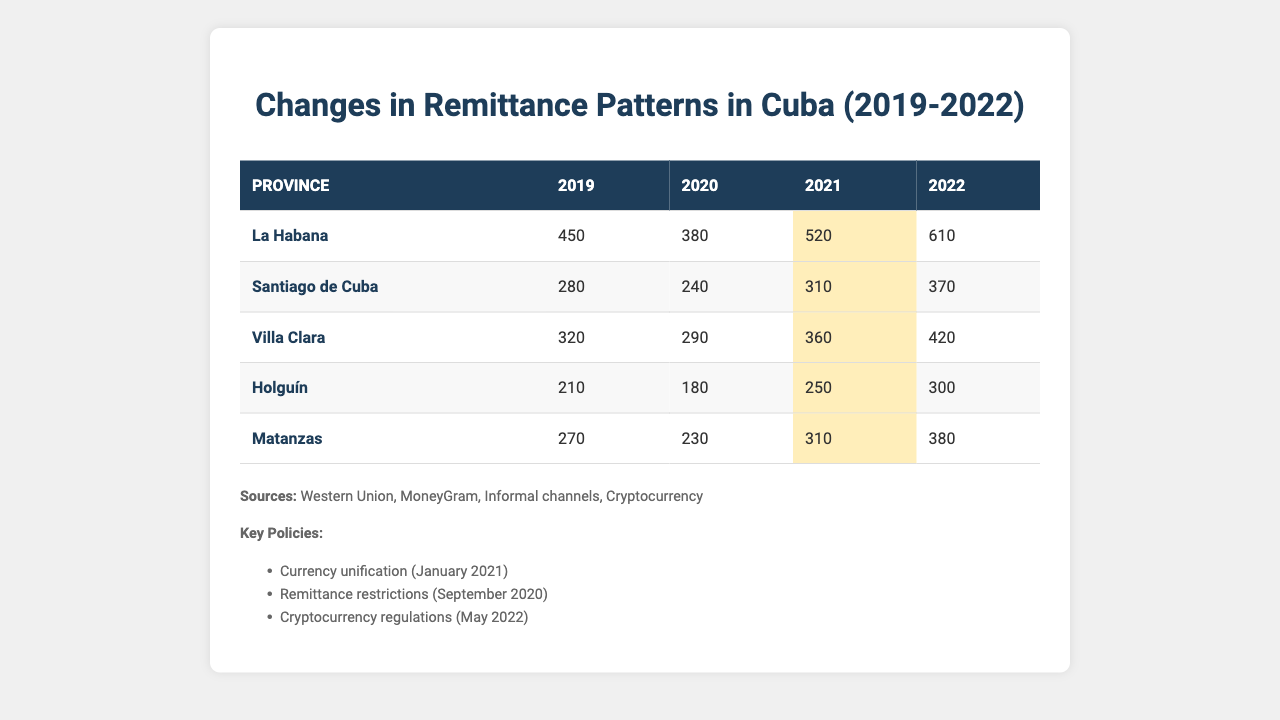What was the remittance amount in La Habana in 2021? According to the table, the remittance amount in La Habana for the year 2021 is directly indicated as 520.
Answer: 520 Which province experienced the highest remittance in 2022? The table shows the remittance amounts for 2022, with La Habana at 610, Santiago de Cuba at 370, Villa Clara at 420, Holguín at 300, and Matanzas at 380. La Habana has the highest remittance amount at 610.
Answer: La Habana What was the percentage increase in remittances from 2019 to 2022 for Holguín? For Holguín, remittances were 210 in 2019 and rose to 300 in 2022. The increase is calculated as (300 - 210) / 210 * 100 = 42.86%.
Answer: 42.86% Did remittances in Santiago de Cuba decrease from 2019 to 2020? The table shows that Santiago de Cuba had remittances of 280 in 2019 and 240 in 2020, indicating a decrease.
Answer: Yes What is the total remittance received in Villa Clara over the four years (2019-2022)? The remittances in Villa Clara are 320 in 2019, 290 in 2020, 360 in 2021, and 420 in 2022. The total can be calculated as 320 + 290 + 360 + 420 = 1390.
Answer: 1390 Which years saw an increase in remittances compared to the previous year for La Habana? Looking at the remittance data for La Habana, it shows an increase from 2019 to 2021 (from 450 to 520) and from 2021 to 2022 (from 520 to 610). However, it decreased from 2019 to 2020 (from 450 to 380). Therefore, the years with increases are 2021 and 2022.
Answer: 2021 and 2022 What was the average remittance amount for Matanzas from 2019 to 2022? Matanzas had remittances of 270 in 2019, 230 in 2020, 310 in 2021, and 380 in 2022. The average is (270 + 230 + 310 + 380) / 4 = 297.5.
Answer: 297.5 Is it true that all provinces experienced an increase in remittances from 2021 to 2022? By examining the data, Holguín (250 to 300), Matanzas (310 to 380), Villa Clara (360 to 420), Santiago de Cuba (310 to 370), and La Habana (520 to 610) all increased from 2021 to 2022. Therefore, the statement is true.
Answer: Yes Which province had the second highest remittance amount in 2020? The table lists the remittance amounts for 2020: La Habana at 380, Santiago de Cuba at 240, Villa Clara at 290, Holguín at 180, and Matanzas at 230. The second highest after La Habana is Villa Clara at 290.
Answer: Villa Clara What was the growth in remittances for La Habana from 2019 to 2022? La Habana had remittances of 450 in 2019 and 610 in 2022. The growth is calculated as (610 - 450) = 160, showing an absolute increase of 160.
Answer: 160 